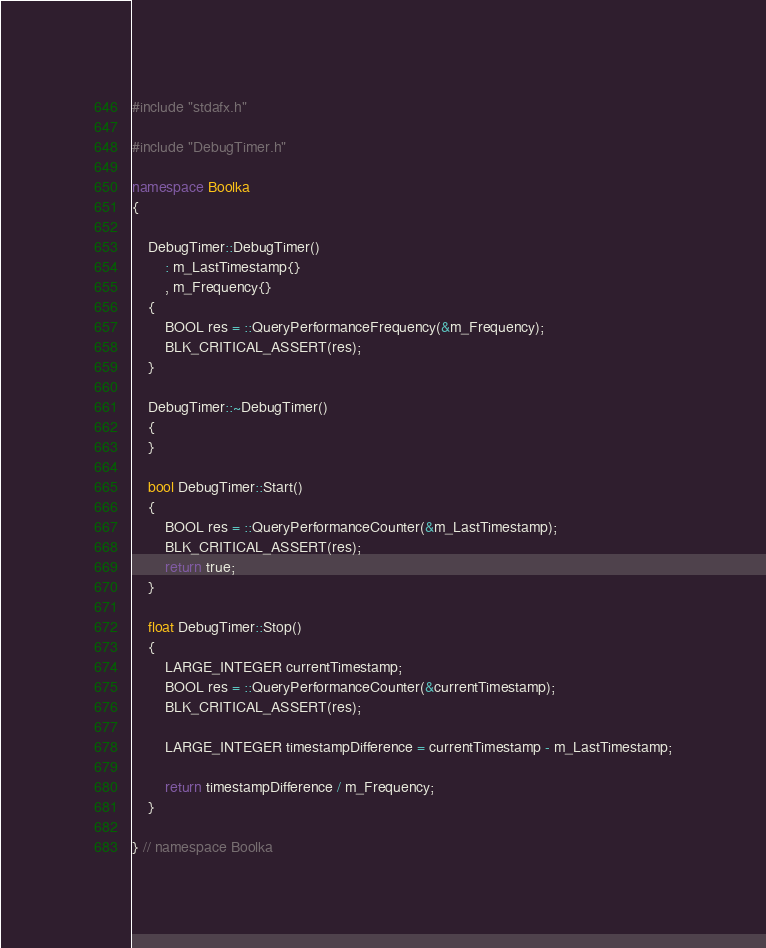<code> <loc_0><loc_0><loc_500><loc_500><_C++_>#include "stdafx.h"

#include "DebugTimer.h"

namespace Boolka
{

    DebugTimer::DebugTimer()
        : m_LastTimestamp{}
        , m_Frequency{}
    {
        BOOL res = ::QueryPerformanceFrequency(&m_Frequency);
        BLK_CRITICAL_ASSERT(res);
    }

    DebugTimer::~DebugTimer()
    {
    }

    bool DebugTimer::Start()
    {
        BOOL res = ::QueryPerformanceCounter(&m_LastTimestamp);
        BLK_CRITICAL_ASSERT(res);
        return true;
    }

    float DebugTimer::Stop()
    {
        LARGE_INTEGER currentTimestamp;
        BOOL res = ::QueryPerformanceCounter(&currentTimestamp);
        BLK_CRITICAL_ASSERT(res);

        LARGE_INTEGER timestampDifference = currentTimestamp - m_LastTimestamp;

        return timestampDifference / m_Frequency;
    }

} // namespace Boolka
</code> 